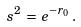<formula> <loc_0><loc_0><loc_500><loc_500>s ^ { 2 } \, = \, e ^ { - r _ { 0 } } \, .</formula> 